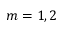Convert formula to latex. <formula><loc_0><loc_0><loc_500><loc_500>m = 1 , 2</formula> 